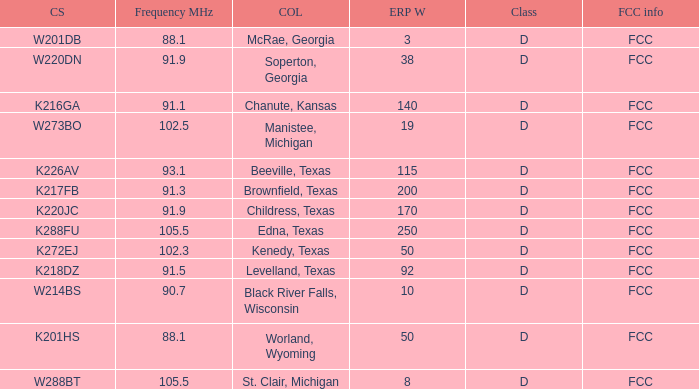What is Call Sign, when ERP W is greater than 50? K216GA, K226AV, K217FB, K220JC, K288FU, K218DZ. 